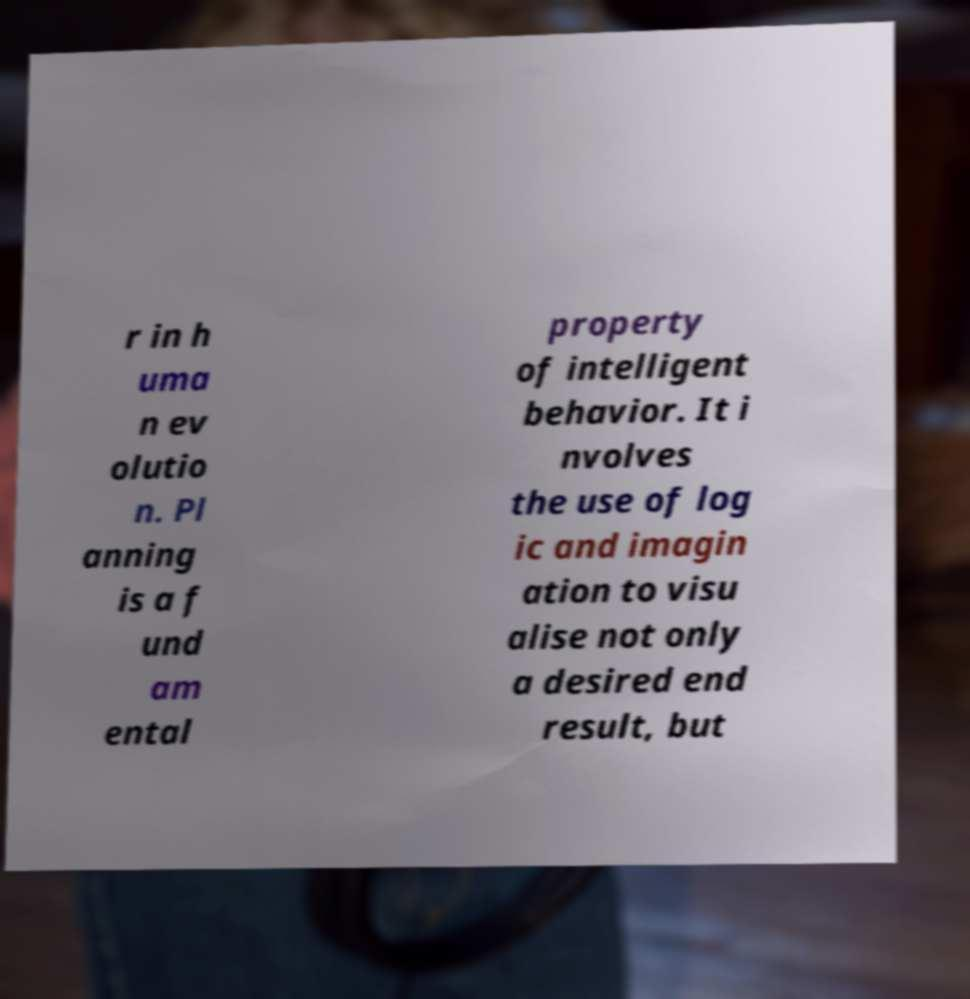What messages or text are displayed in this image? I need them in a readable, typed format. r in h uma n ev olutio n. Pl anning is a f und am ental property of intelligent behavior. It i nvolves the use of log ic and imagin ation to visu alise not only a desired end result, but 